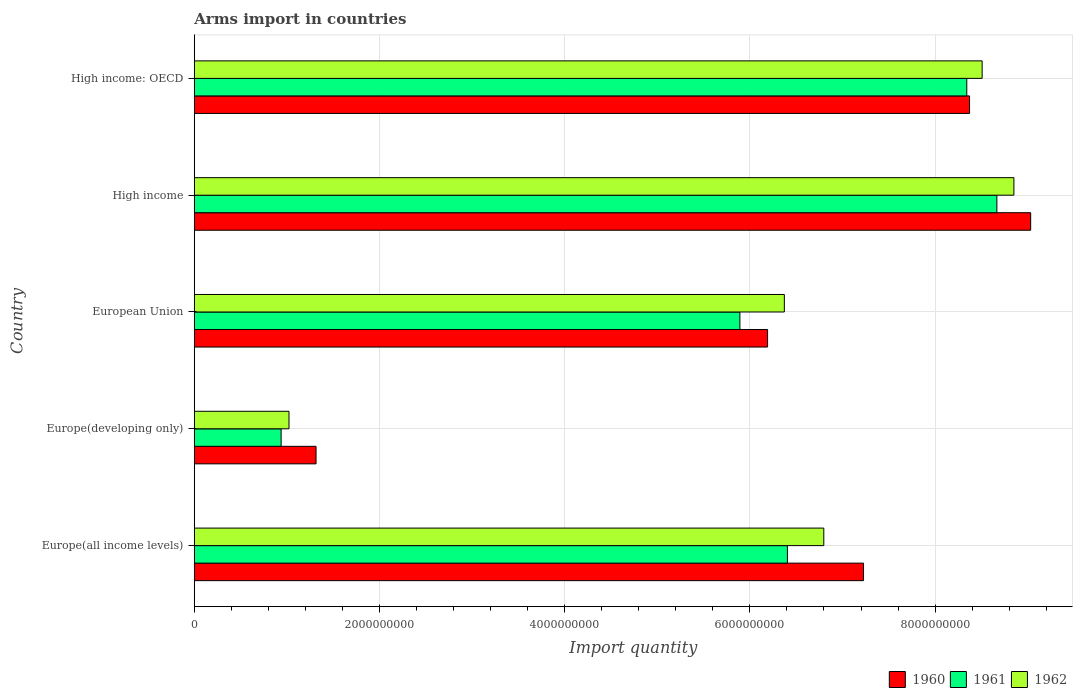How many bars are there on the 2nd tick from the top?
Provide a short and direct response. 3. What is the label of the 2nd group of bars from the top?
Keep it short and to the point. High income. In how many cases, is the number of bars for a given country not equal to the number of legend labels?
Your answer should be very brief. 0. What is the total arms import in 1961 in High income: OECD?
Offer a terse response. 8.34e+09. Across all countries, what is the maximum total arms import in 1960?
Make the answer very short. 9.03e+09. Across all countries, what is the minimum total arms import in 1961?
Offer a very short reply. 9.38e+08. In which country was the total arms import in 1961 minimum?
Provide a succinct answer. Europe(developing only). What is the total total arms import in 1962 in the graph?
Give a very brief answer. 3.16e+1. What is the difference between the total arms import in 1960 in Europe(all income levels) and that in High income?
Provide a succinct answer. -1.80e+09. What is the difference between the total arms import in 1960 in Europe(developing only) and the total arms import in 1962 in European Union?
Provide a succinct answer. -5.06e+09. What is the average total arms import in 1962 per country?
Make the answer very short. 6.31e+09. What is the difference between the total arms import in 1961 and total arms import in 1960 in High income: OECD?
Your response must be concise. -3.00e+07. What is the ratio of the total arms import in 1962 in Europe(all income levels) to that in Europe(developing only)?
Ensure brevity in your answer.  6.65. What is the difference between the highest and the second highest total arms import in 1962?
Give a very brief answer. 3.43e+08. What is the difference between the highest and the lowest total arms import in 1960?
Provide a succinct answer. 7.72e+09. What does the 3rd bar from the top in Europe(developing only) represents?
Provide a short and direct response. 1960. How many countries are there in the graph?
Your response must be concise. 5. What is the difference between two consecutive major ticks on the X-axis?
Make the answer very short. 2.00e+09. Are the values on the major ticks of X-axis written in scientific E-notation?
Provide a short and direct response. No. Does the graph contain grids?
Your answer should be compact. Yes. How many legend labels are there?
Your answer should be very brief. 3. How are the legend labels stacked?
Your answer should be compact. Horizontal. What is the title of the graph?
Keep it short and to the point. Arms import in countries. Does "1993" appear as one of the legend labels in the graph?
Provide a short and direct response. No. What is the label or title of the X-axis?
Offer a very short reply. Import quantity. What is the label or title of the Y-axis?
Your answer should be compact. Country. What is the Import quantity of 1960 in Europe(all income levels)?
Your answer should be compact. 7.23e+09. What is the Import quantity of 1961 in Europe(all income levels)?
Offer a very short reply. 6.40e+09. What is the Import quantity in 1962 in Europe(all income levels)?
Your response must be concise. 6.80e+09. What is the Import quantity of 1960 in Europe(developing only)?
Your answer should be very brief. 1.32e+09. What is the Import quantity of 1961 in Europe(developing only)?
Your answer should be compact. 9.38e+08. What is the Import quantity in 1962 in Europe(developing only)?
Offer a very short reply. 1.02e+09. What is the Import quantity of 1960 in European Union?
Keep it short and to the point. 6.19e+09. What is the Import quantity in 1961 in European Union?
Offer a very short reply. 5.89e+09. What is the Import quantity in 1962 in European Union?
Ensure brevity in your answer.  6.37e+09. What is the Import quantity of 1960 in High income?
Provide a short and direct response. 9.03e+09. What is the Import quantity in 1961 in High income?
Your answer should be compact. 8.67e+09. What is the Import quantity in 1962 in High income?
Keep it short and to the point. 8.85e+09. What is the Import quantity in 1960 in High income: OECD?
Make the answer very short. 8.37e+09. What is the Import quantity in 1961 in High income: OECD?
Provide a short and direct response. 8.34e+09. What is the Import quantity in 1962 in High income: OECD?
Your answer should be compact. 8.51e+09. Across all countries, what is the maximum Import quantity of 1960?
Make the answer very short. 9.03e+09. Across all countries, what is the maximum Import quantity of 1961?
Provide a succinct answer. 8.67e+09. Across all countries, what is the maximum Import quantity of 1962?
Keep it short and to the point. 8.85e+09. Across all countries, what is the minimum Import quantity of 1960?
Provide a succinct answer. 1.32e+09. Across all countries, what is the minimum Import quantity in 1961?
Ensure brevity in your answer.  9.38e+08. Across all countries, what is the minimum Import quantity in 1962?
Keep it short and to the point. 1.02e+09. What is the total Import quantity of 1960 in the graph?
Ensure brevity in your answer.  3.21e+1. What is the total Import quantity of 1961 in the graph?
Your answer should be very brief. 3.02e+1. What is the total Import quantity in 1962 in the graph?
Your answer should be compact. 3.16e+1. What is the difference between the Import quantity in 1960 in Europe(all income levels) and that in Europe(developing only)?
Your response must be concise. 5.91e+09. What is the difference between the Import quantity of 1961 in Europe(all income levels) and that in Europe(developing only)?
Your answer should be very brief. 5.47e+09. What is the difference between the Import quantity of 1962 in Europe(all income levels) and that in Europe(developing only)?
Your answer should be very brief. 5.78e+09. What is the difference between the Import quantity of 1960 in Europe(all income levels) and that in European Union?
Provide a short and direct response. 1.04e+09. What is the difference between the Import quantity of 1961 in Europe(all income levels) and that in European Union?
Your answer should be very brief. 5.13e+08. What is the difference between the Import quantity of 1962 in Europe(all income levels) and that in European Union?
Your answer should be compact. 4.26e+08. What is the difference between the Import quantity in 1960 in Europe(all income levels) and that in High income?
Keep it short and to the point. -1.80e+09. What is the difference between the Import quantity of 1961 in Europe(all income levels) and that in High income?
Your answer should be compact. -2.26e+09. What is the difference between the Import quantity of 1962 in Europe(all income levels) and that in High income?
Offer a very short reply. -2.05e+09. What is the difference between the Import quantity of 1960 in Europe(all income levels) and that in High income: OECD?
Give a very brief answer. -1.14e+09. What is the difference between the Import quantity of 1961 in Europe(all income levels) and that in High income: OECD?
Provide a succinct answer. -1.94e+09. What is the difference between the Import quantity of 1962 in Europe(all income levels) and that in High income: OECD?
Provide a succinct answer. -1.71e+09. What is the difference between the Import quantity in 1960 in Europe(developing only) and that in European Union?
Ensure brevity in your answer.  -4.88e+09. What is the difference between the Import quantity in 1961 in Europe(developing only) and that in European Union?
Make the answer very short. -4.95e+09. What is the difference between the Import quantity in 1962 in Europe(developing only) and that in European Union?
Make the answer very short. -5.35e+09. What is the difference between the Import quantity in 1960 in Europe(developing only) and that in High income?
Your answer should be compact. -7.72e+09. What is the difference between the Import quantity in 1961 in Europe(developing only) and that in High income?
Provide a succinct answer. -7.73e+09. What is the difference between the Import quantity of 1962 in Europe(developing only) and that in High income?
Make the answer very short. -7.83e+09. What is the difference between the Import quantity in 1960 in Europe(developing only) and that in High income: OECD?
Make the answer very short. -7.06e+09. What is the difference between the Import quantity of 1961 in Europe(developing only) and that in High income: OECD?
Your answer should be compact. -7.40e+09. What is the difference between the Import quantity of 1962 in Europe(developing only) and that in High income: OECD?
Provide a short and direct response. -7.48e+09. What is the difference between the Import quantity in 1960 in European Union and that in High income?
Ensure brevity in your answer.  -2.84e+09. What is the difference between the Import quantity of 1961 in European Union and that in High income?
Offer a terse response. -2.78e+09. What is the difference between the Import quantity of 1962 in European Union and that in High income?
Your response must be concise. -2.48e+09. What is the difference between the Import quantity of 1960 in European Union and that in High income: OECD?
Offer a very short reply. -2.18e+09. What is the difference between the Import quantity of 1961 in European Union and that in High income: OECD?
Give a very brief answer. -2.45e+09. What is the difference between the Import quantity of 1962 in European Union and that in High income: OECD?
Provide a short and direct response. -2.14e+09. What is the difference between the Import quantity in 1960 in High income and that in High income: OECD?
Ensure brevity in your answer.  6.60e+08. What is the difference between the Import quantity of 1961 in High income and that in High income: OECD?
Make the answer very short. 3.25e+08. What is the difference between the Import quantity in 1962 in High income and that in High income: OECD?
Give a very brief answer. 3.43e+08. What is the difference between the Import quantity of 1960 in Europe(all income levels) and the Import quantity of 1961 in Europe(developing only)?
Your answer should be compact. 6.29e+09. What is the difference between the Import quantity of 1960 in Europe(all income levels) and the Import quantity of 1962 in Europe(developing only)?
Offer a terse response. 6.20e+09. What is the difference between the Import quantity of 1961 in Europe(all income levels) and the Import quantity of 1962 in Europe(developing only)?
Make the answer very short. 5.38e+09. What is the difference between the Import quantity in 1960 in Europe(all income levels) and the Import quantity in 1961 in European Union?
Make the answer very short. 1.34e+09. What is the difference between the Import quantity of 1960 in Europe(all income levels) and the Import quantity of 1962 in European Union?
Offer a terse response. 8.55e+08. What is the difference between the Import quantity in 1961 in Europe(all income levels) and the Import quantity in 1962 in European Union?
Offer a terse response. 3.30e+07. What is the difference between the Import quantity in 1960 in Europe(all income levels) and the Import quantity in 1961 in High income?
Your answer should be compact. -1.44e+09. What is the difference between the Import quantity of 1960 in Europe(all income levels) and the Import quantity of 1962 in High income?
Keep it short and to the point. -1.62e+09. What is the difference between the Import quantity in 1961 in Europe(all income levels) and the Import quantity in 1962 in High income?
Provide a succinct answer. -2.45e+09. What is the difference between the Import quantity in 1960 in Europe(all income levels) and the Import quantity in 1961 in High income: OECD?
Offer a terse response. -1.12e+09. What is the difference between the Import quantity of 1960 in Europe(all income levels) and the Import quantity of 1962 in High income: OECD?
Offer a very short reply. -1.28e+09. What is the difference between the Import quantity in 1961 in Europe(all income levels) and the Import quantity in 1962 in High income: OECD?
Offer a very short reply. -2.10e+09. What is the difference between the Import quantity of 1960 in Europe(developing only) and the Import quantity of 1961 in European Union?
Your response must be concise. -4.58e+09. What is the difference between the Import quantity in 1960 in Europe(developing only) and the Import quantity in 1962 in European Union?
Offer a terse response. -5.06e+09. What is the difference between the Import quantity of 1961 in Europe(developing only) and the Import quantity of 1962 in European Union?
Your response must be concise. -5.43e+09. What is the difference between the Import quantity in 1960 in Europe(developing only) and the Import quantity in 1961 in High income?
Keep it short and to the point. -7.35e+09. What is the difference between the Import quantity of 1960 in Europe(developing only) and the Import quantity of 1962 in High income?
Your answer should be compact. -7.54e+09. What is the difference between the Import quantity of 1961 in Europe(developing only) and the Import quantity of 1962 in High income?
Offer a terse response. -7.91e+09. What is the difference between the Import quantity of 1960 in Europe(developing only) and the Import quantity of 1961 in High income: OECD?
Offer a terse response. -7.03e+09. What is the difference between the Import quantity of 1960 in Europe(developing only) and the Import quantity of 1962 in High income: OECD?
Provide a succinct answer. -7.19e+09. What is the difference between the Import quantity in 1961 in Europe(developing only) and the Import quantity in 1962 in High income: OECD?
Provide a short and direct response. -7.57e+09. What is the difference between the Import quantity in 1960 in European Union and the Import quantity in 1961 in High income?
Give a very brief answer. -2.48e+09. What is the difference between the Import quantity of 1960 in European Union and the Import quantity of 1962 in High income?
Offer a terse response. -2.66e+09. What is the difference between the Import quantity in 1961 in European Union and the Import quantity in 1962 in High income?
Your response must be concise. -2.96e+09. What is the difference between the Import quantity of 1960 in European Union and the Import quantity of 1961 in High income: OECD?
Make the answer very short. -2.15e+09. What is the difference between the Import quantity of 1960 in European Union and the Import quantity of 1962 in High income: OECD?
Your response must be concise. -2.32e+09. What is the difference between the Import quantity in 1961 in European Union and the Import quantity in 1962 in High income: OECD?
Your answer should be very brief. -2.62e+09. What is the difference between the Import quantity in 1960 in High income and the Import quantity in 1961 in High income: OECD?
Make the answer very short. 6.90e+08. What is the difference between the Import quantity in 1960 in High income and the Import quantity in 1962 in High income: OECD?
Make the answer very short. 5.24e+08. What is the difference between the Import quantity in 1961 in High income and the Import quantity in 1962 in High income: OECD?
Your answer should be compact. 1.59e+08. What is the average Import quantity of 1960 per country?
Make the answer very short. 6.43e+09. What is the average Import quantity in 1961 per country?
Make the answer very short. 6.05e+09. What is the average Import quantity in 1962 per country?
Your response must be concise. 6.31e+09. What is the difference between the Import quantity in 1960 and Import quantity in 1961 in Europe(all income levels)?
Give a very brief answer. 8.22e+08. What is the difference between the Import quantity in 1960 and Import quantity in 1962 in Europe(all income levels)?
Offer a very short reply. 4.29e+08. What is the difference between the Import quantity of 1961 and Import quantity of 1962 in Europe(all income levels)?
Your answer should be very brief. -3.93e+08. What is the difference between the Import quantity of 1960 and Import quantity of 1961 in Europe(developing only)?
Your answer should be very brief. 3.77e+08. What is the difference between the Import quantity of 1960 and Import quantity of 1962 in Europe(developing only)?
Ensure brevity in your answer.  2.92e+08. What is the difference between the Import quantity in 1961 and Import quantity in 1962 in Europe(developing only)?
Offer a very short reply. -8.50e+07. What is the difference between the Import quantity of 1960 and Import quantity of 1961 in European Union?
Your answer should be very brief. 2.99e+08. What is the difference between the Import quantity of 1960 and Import quantity of 1962 in European Union?
Your answer should be very brief. -1.81e+08. What is the difference between the Import quantity of 1961 and Import quantity of 1962 in European Union?
Ensure brevity in your answer.  -4.80e+08. What is the difference between the Import quantity in 1960 and Import quantity in 1961 in High income?
Keep it short and to the point. 3.65e+08. What is the difference between the Import quantity of 1960 and Import quantity of 1962 in High income?
Make the answer very short. 1.81e+08. What is the difference between the Import quantity of 1961 and Import quantity of 1962 in High income?
Provide a succinct answer. -1.84e+08. What is the difference between the Import quantity in 1960 and Import quantity in 1961 in High income: OECD?
Your answer should be compact. 3.00e+07. What is the difference between the Import quantity of 1960 and Import quantity of 1962 in High income: OECD?
Offer a terse response. -1.36e+08. What is the difference between the Import quantity of 1961 and Import quantity of 1962 in High income: OECD?
Your response must be concise. -1.66e+08. What is the ratio of the Import quantity in 1960 in Europe(all income levels) to that in Europe(developing only)?
Give a very brief answer. 5.5. What is the ratio of the Import quantity in 1961 in Europe(all income levels) to that in Europe(developing only)?
Provide a short and direct response. 6.83. What is the ratio of the Import quantity of 1962 in Europe(all income levels) to that in Europe(developing only)?
Give a very brief answer. 6.65. What is the ratio of the Import quantity in 1960 in Europe(all income levels) to that in European Union?
Provide a succinct answer. 1.17. What is the ratio of the Import quantity of 1961 in Europe(all income levels) to that in European Union?
Offer a terse response. 1.09. What is the ratio of the Import quantity in 1962 in Europe(all income levels) to that in European Union?
Keep it short and to the point. 1.07. What is the ratio of the Import quantity of 1960 in Europe(all income levels) to that in High income?
Offer a very short reply. 0.8. What is the ratio of the Import quantity of 1961 in Europe(all income levels) to that in High income?
Make the answer very short. 0.74. What is the ratio of the Import quantity of 1962 in Europe(all income levels) to that in High income?
Your answer should be very brief. 0.77. What is the ratio of the Import quantity of 1960 in Europe(all income levels) to that in High income: OECD?
Offer a very short reply. 0.86. What is the ratio of the Import quantity of 1961 in Europe(all income levels) to that in High income: OECD?
Keep it short and to the point. 0.77. What is the ratio of the Import quantity in 1962 in Europe(all income levels) to that in High income: OECD?
Give a very brief answer. 0.8. What is the ratio of the Import quantity in 1960 in Europe(developing only) to that in European Union?
Provide a succinct answer. 0.21. What is the ratio of the Import quantity of 1961 in Europe(developing only) to that in European Union?
Offer a terse response. 0.16. What is the ratio of the Import quantity in 1962 in Europe(developing only) to that in European Union?
Make the answer very short. 0.16. What is the ratio of the Import quantity of 1960 in Europe(developing only) to that in High income?
Provide a succinct answer. 0.15. What is the ratio of the Import quantity of 1961 in Europe(developing only) to that in High income?
Make the answer very short. 0.11. What is the ratio of the Import quantity in 1962 in Europe(developing only) to that in High income?
Your response must be concise. 0.12. What is the ratio of the Import quantity in 1960 in Europe(developing only) to that in High income: OECD?
Give a very brief answer. 0.16. What is the ratio of the Import quantity in 1961 in Europe(developing only) to that in High income: OECD?
Keep it short and to the point. 0.11. What is the ratio of the Import quantity of 1962 in Europe(developing only) to that in High income: OECD?
Offer a terse response. 0.12. What is the ratio of the Import quantity in 1960 in European Union to that in High income?
Offer a terse response. 0.69. What is the ratio of the Import quantity of 1961 in European Union to that in High income?
Provide a succinct answer. 0.68. What is the ratio of the Import quantity of 1962 in European Union to that in High income?
Your response must be concise. 0.72. What is the ratio of the Import quantity in 1960 in European Union to that in High income: OECD?
Your answer should be very brief. 0.74. What is the ratio of the Import quantity of 1961 in European Union to that in High income: OECD?
Your answer should be compact. 0.71. What is the ratio of the Import quantity of 1962 in European Union to that in High income: OECD?
Your answer should be very brief. 0.75. What is the ratio of the Import quantity in 1960 in High income to that in High income: OECD?
Give a very brief answer. 1.08. What is the ratio of the Import quantity in 1961 in High income to that in High income: OECD?
Offer a very short reply. 1.04. What is the ratio of the Import quantity of 1962 in High income to that in High income: OECD?
Keep it short and to the point. 1.04. What is the difference between the highest and the second highest Import quantity of 1960?
Ensure brevity in your answer.  6.60e+08. What is the difference between the highest and the second highest Import quantity of 1961?
Give a very brief answer. 3.25e+08. What is the difference between the highest and the second highest Import quantity of 1962?
Your answer should be compact. 3.43e+08. What is the difference between the highest and the lowest Import quantity of 1960?
Ensure brevity in your answer.  7.72e+09. What is the difference between the highest and the lowest Import quantity in 1961?
Give a very brief answer. 7.73e+09. What is the difference between the highest and the lowest Import quantity in 1962?
Offer a very short reply. 7.83e+09. 